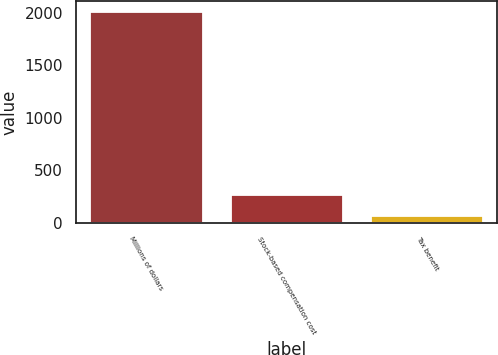Convert chart. <chart><loc_0><loc_0><loc_500><loc_500><bar_chart><fcel>Millions of dollars<fcel>Stock-based compensation cost<fcel>Tax benefit<nl><fcel>2012<fcel>261.5<fcel>67<nl></chart> 